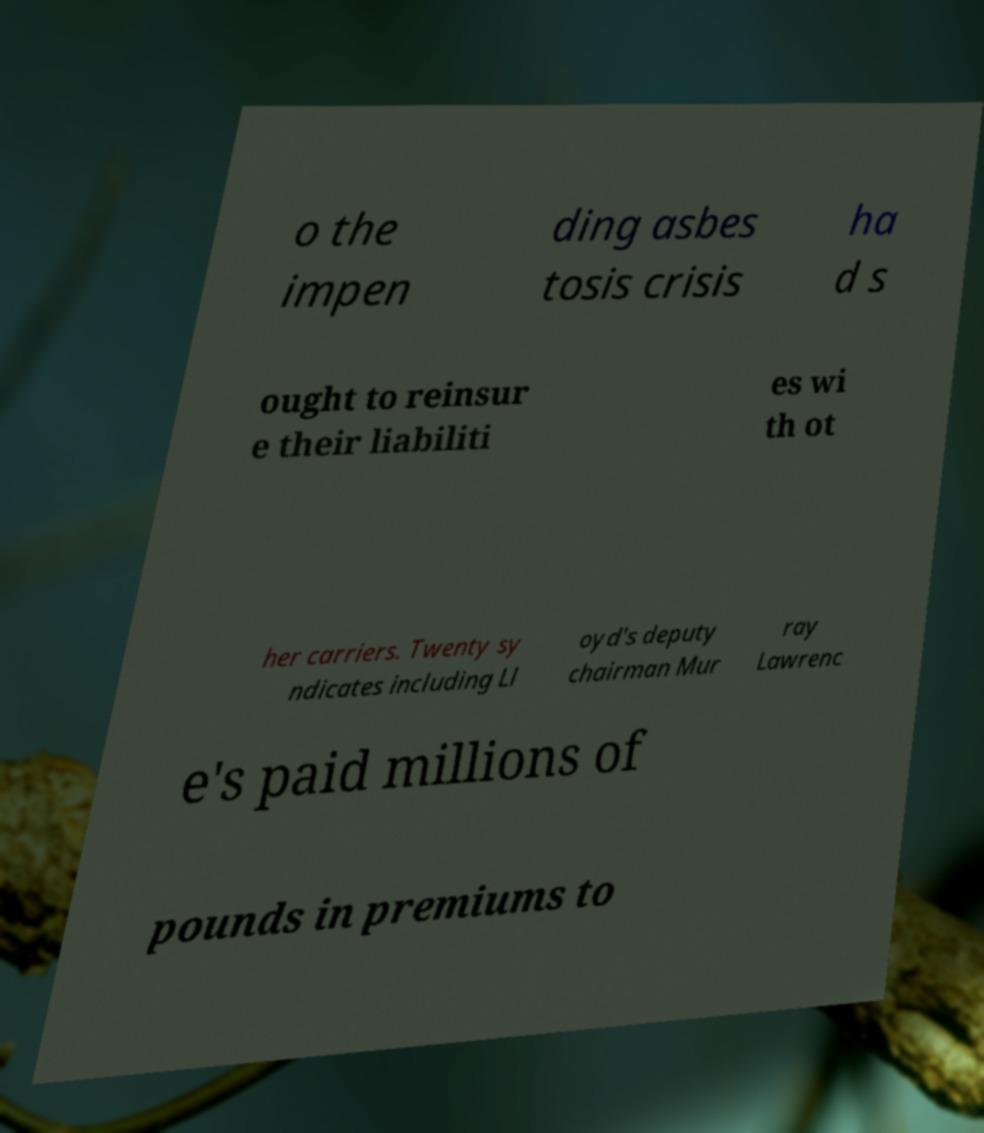Please identify and transcribe the text found in this image. o the impen ding asbes tosis crisis ha d s ought to reinsur e their liabiliti es wi th ot her carriers. Twenty sy ndicates including Ll oyd's deputy chairman Mur ray Lawrenc e's paid millions of pounds in premiums to 